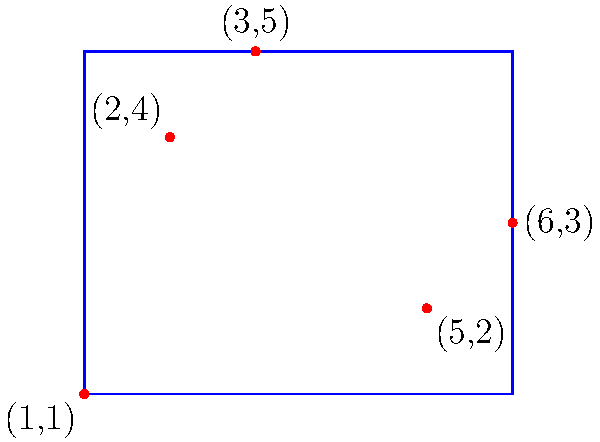Given a set of 2D points $\{(1,1), (2,4), (5,2), (3,5), (6,3)\}$, what is the area of the minimum bounding box that encloses all these points? To find the area of the minimum bounding box, we need to follow these steps:

1. Determine the minimum and maximum x and y coordinates:
   $x_{min} = 1$, $x_{max} = 6$
   $y_{min} = 1$, $y_{max} = 5$

2. Calculate the width and height of the bounding box:
   Width $w = x_{max} - x_{min} = 6 - 1 = 5$
   Height $h = y_{max} - y_{min} = 5 - 1 = 4$

3. Calculate the area of the bounding box:
   Area $A = w \times h = 5 \times 4 = 20$

Therefore, the area of the minimum bounding box is 20 square units.
Answer: 20 square units 